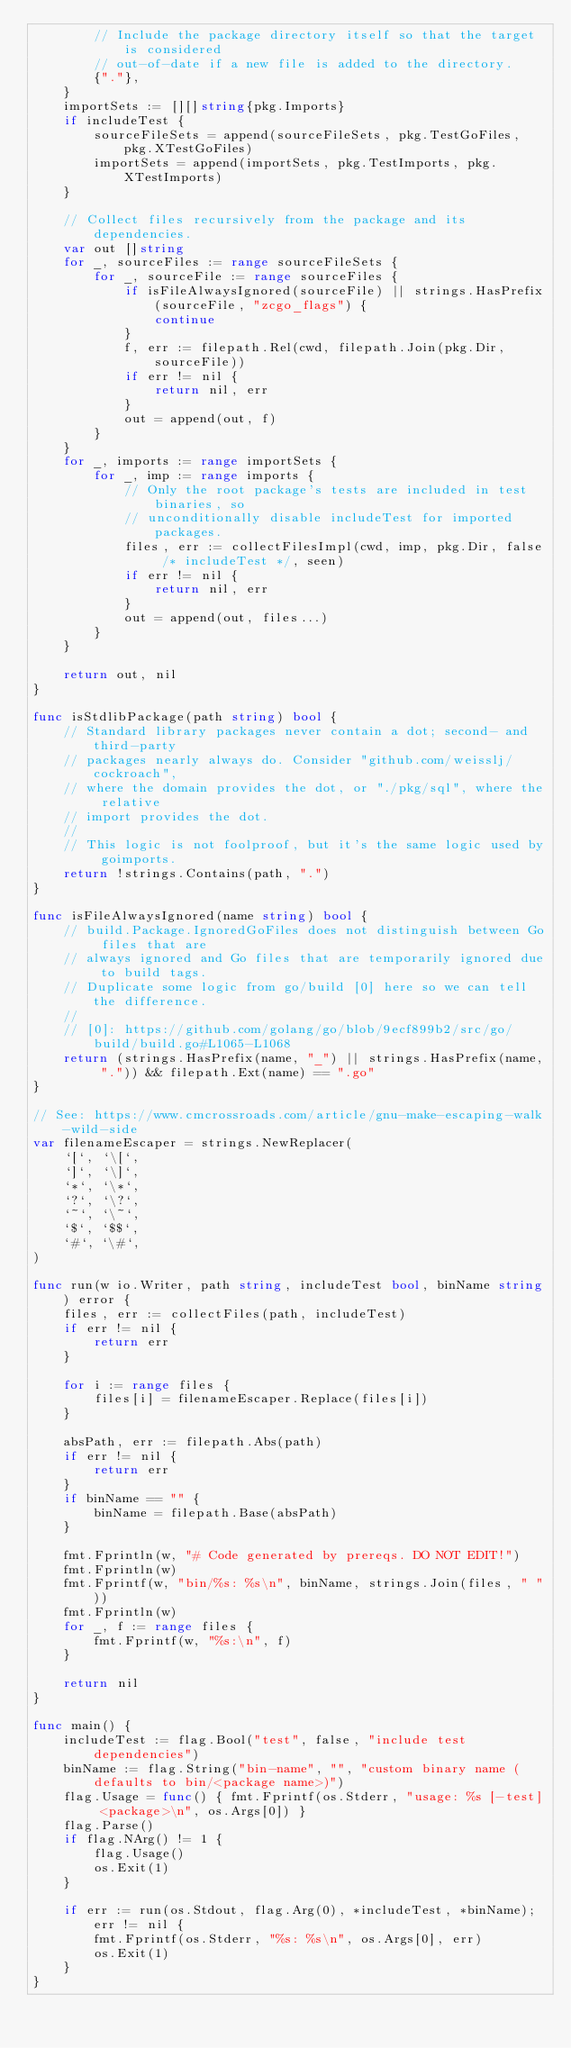<code> <loc_0><loc_0><loc_500><loc_500><_Go_>		// Include the package directory itself so that the target is considered
		// out-of-date if a new file is added to the directory.
		{"."},
	}
	importSets := [][]string{pkg.Imports}
	if includeTest {
		sourceFileSets = append(sourceFileSets, pkg.TestGoFiles, pkg.XTestGoFiles)
		importSets = append(importSets, pkg.TestImports, pkg.XTestImports)
	}

	// Collect files recursively from the package and its dependencies.
	var out []string
	for _, sourceFiles := range sourceFileSets {
		for _, sourceFile := range sourceFiles {
			if isFileAlwaysIgnored(sourceFile) || strings.HasPrefix(sourceFile, "zcgo_flags") {
				continue
			}
			f, err := filepath.Rel(cwd, filepath.Join(pkg.Dir, sourceFile))
			if err != nil {
				return nil, err
			}
			out = append(out, f)
		}
	}
	for _, imports := range importSets {
		for _, imp := range imports {
			// Only the root package's tests are included in test binaries, so
			// unconditionally disable includeTest for imported packages.
			files, err := collectFilesImpl(cwd, imp, pkg.Dir, false /* includeTest */, seen)
			if err != nil {
				return nil, err
			}
			out = append(out, files...)
		}
	}

	return out, nil
}

func isStdlibPackage(path string) bool {
	// Standard library packages never contain a dot; second- and third-party
	// packages nearly always do. Consider "github.com/weisslj/cockroach",
	// where the domain provides the dot, or "./pkg/sql", where the relative
	// import provides the dot.
	//
	// This logic is not foolproof, but it's the same logic used by goimports.
	return !strings.Contains(path, ".")
}

func isFileAlwaysIgnored(name string) bool {
	// build.Package.IgnoredGoFiles does not distinguish between Go files that are
	// always ignored and Go files that are temporarily ignored due to build tags.
	// Duplicate some logic from go/build [0] here so we can tell the difference.
	//
	// [0]: https://github.com/golang/go/blob/9ecf899b2/src/go/build/build.go#L1065-L1068
	return (strings.HasPrefix(name, "_") || strings.HasPrefix(name, ".")) && filepath.Ext(name) == ".go"
}

// See: https://www.cmcrossroads.com/article/gnu-make-escaping-walk-wild-side
var filenameEscaper = strings.NewReplacer(
	`[`, `\[`,
	`]`, `\]`,
	`*`, `\*`,
	`?`, `\?`,
	`~`, `\~`,
	`$`, `$$`,
	`#`, `\#`,
)

func run(w io.Writer, path string, includeTest bool, binName string) error {
	files, err := collectFiles(path, includeTest)
	if err != nil {
		return err
	}

	for i := range files {
		files[i] = filenameEscaper.Replace(files[i])
	}

	absPath, err := filepath.Abs(path)
	if err != nil {
		return err
	}
	if binName == "" {
		binName = filepath.Base(absPath)
	}

	fmt.Fprintln(w, "# Code generated by prereqs. DO NOT EDIT!")
	fmt.Fprintln(w)
	fmt.Fprintf(w, "bin/%s: %s\n", binName, strings.Join(files, " "))
	fmt.Fprintln(w)
	for _, f := range files {
		fmt.Fprintf(w, "%s:\n", f)
	}

	return nil
}

func main() {
	includeTest := flag.Bool("test", false, "include test dependencies")
	binName := flag.String("bin-name", "", "custom binary name (defaults to bin/<package name>)")
	flag.Usage = func() { fmt.Fprintf(os.Stderr, "usage: %s [-test] <package>\n", os.Args[0]) }
	flag.Parse()
	if flag.NArg() != 1 {
		flag.Usage()
		os.Exit(1)
	}

	if err := run(os.Stdout, flag.Arg(0), *includeTest, *binName); err != nil {
		fmt.Fprintf(os.Stderr, "%s: %s\n", os.Args[0], err)
		os.Exit(1)
	}
}
</code> 